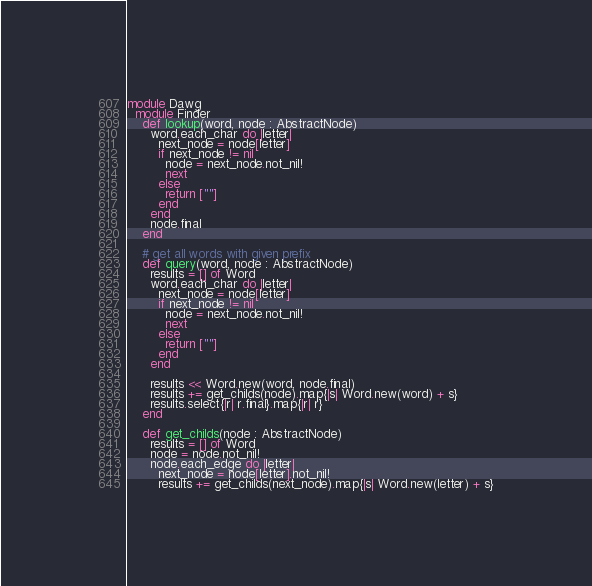Convert code to text. <code><loc_0><loc_0><loc_500><loc_500><_Crystal_>module Dawg
  module Finder
    def lookup(word, node : AbstractNode)
      word.each_char do |letter|
        next_node = node[letter]
        if next_node != nil
          node = next_node.not_nil!
          next
        else
          return [""]
        end
      end
      node.final
    end

    # get all words with given prefix
    def query(word, node : AbstractNode)
      results = [] of Word
      word.each_char do |letter|
        next_node = node[letter]
        if next_node != nil
          node = next_node.not_nil!
          next
        else
          return [""]
        end
      end

      results << Word.new(word, node.final)
      results += get_childs(node).map{|s| Word.new(word) + s}
      results.select{|r| r.final}.map{|r| r}
    end

    def get_childs(node : AbstractNode)
      results = [] of Word
      node = node.not_nil!
      node.each_edge do |letter|
        next_node = node[letter].not_nil!
        results += get_childs(next_node).map{|s| Word.new(letter) + s}</code> 